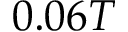<formula> <loc_0><loc_0><loc_500><loc_500>0 . 0 6 T</formula> 